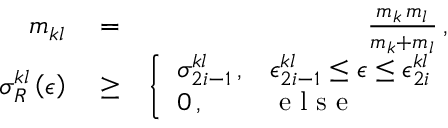<formula> <loc_0><loc_0><loc_500><loc_500>\begin{array} { r l r } { m _ { k l } } & = } & { \frac { m _ { k } \, m _ { l } } { m _ { k } + m _ { l } } \, , } \\ { \sigma _ { R } ^ { k l } \left ( \epsilon \right ) } & \geq } & { \left \{ \begin{array} { l l } { \sigma _ { 2 i - 1 } ^ { k l } \, , } & { \epsilon _ { 2 i - 1 } ^ { k l } \leq \epsilon \leq \epsilon _ { 2 i } ^ { k l } } \\ { 0 \, , } & { e l s e } \end{array} } \end{array}</formula> 